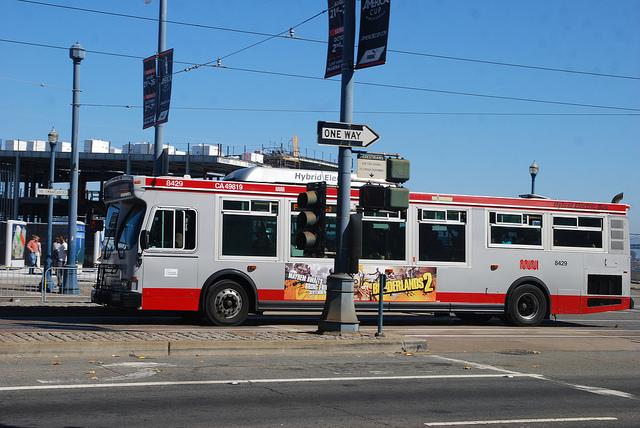What type of company paid to have their product advertised on the bus? Please explain your reasoning. video game. Looks like a new game coming out that is on the side of the bus. 